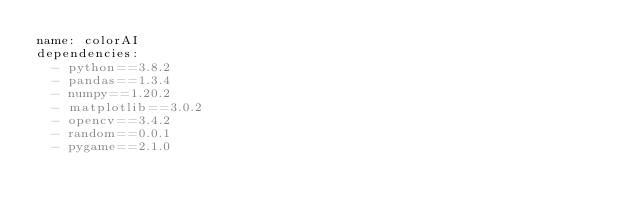<code> <loc_0><loc_0><loc_500><loc_500><_YAML_>name: colorAI
dependencies:
  - python==3.8.2
  - pandas==1.3.4
  - numpy==1.20.2
  - matplotlib==3.0.2
  - opencv==3.4.2
  - random==0.0.1
  - pygame==2.1.0
</code> 